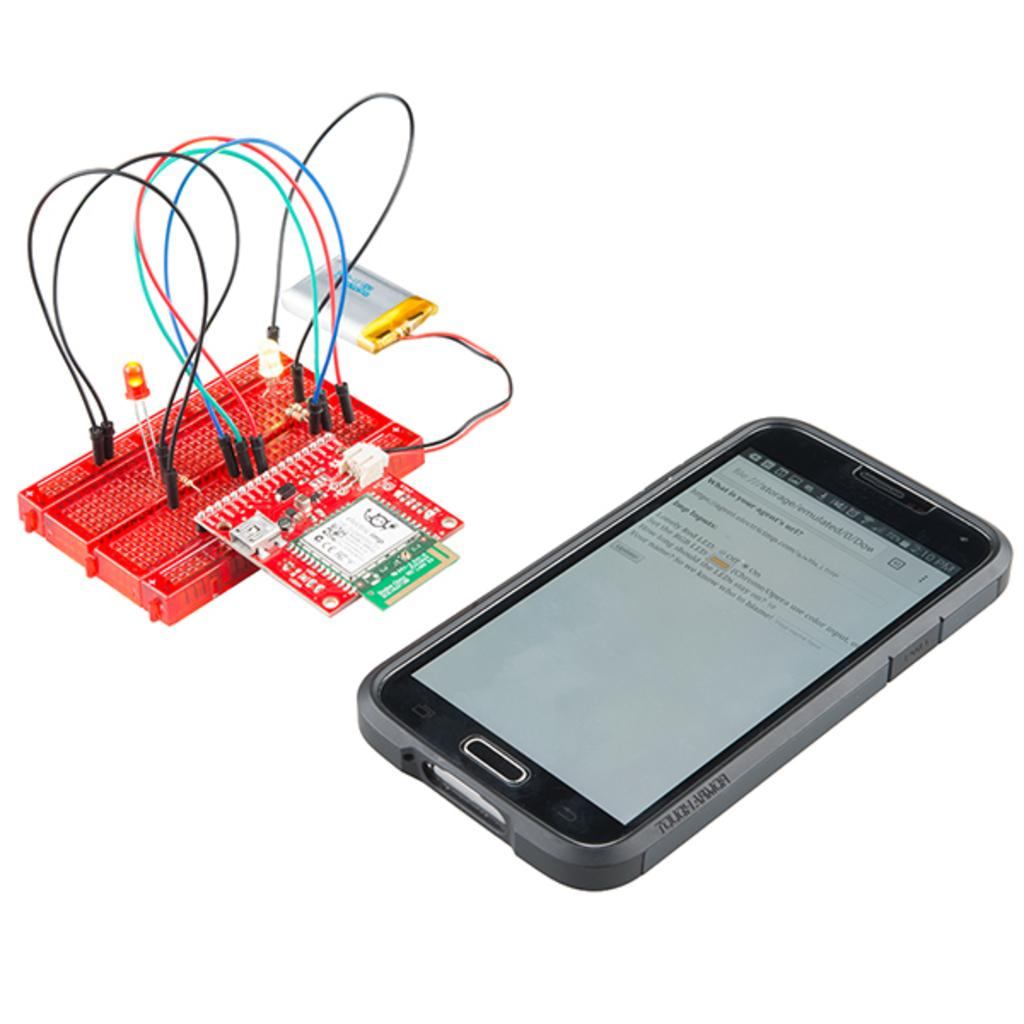<image>
Write a terse but informative summary of the picture. The mobile phone shows that the time is after noon. 